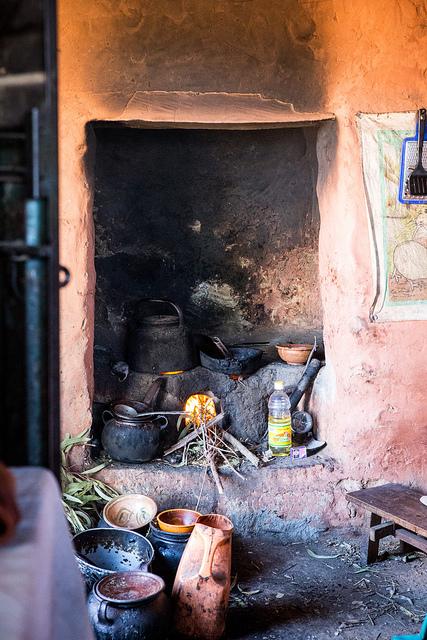How many bottles are in the picture?
Keep it brief. 1. Is this a nice place to live?
Be succinct. No. What is all over the floor?
Short answer required. Dirt. 